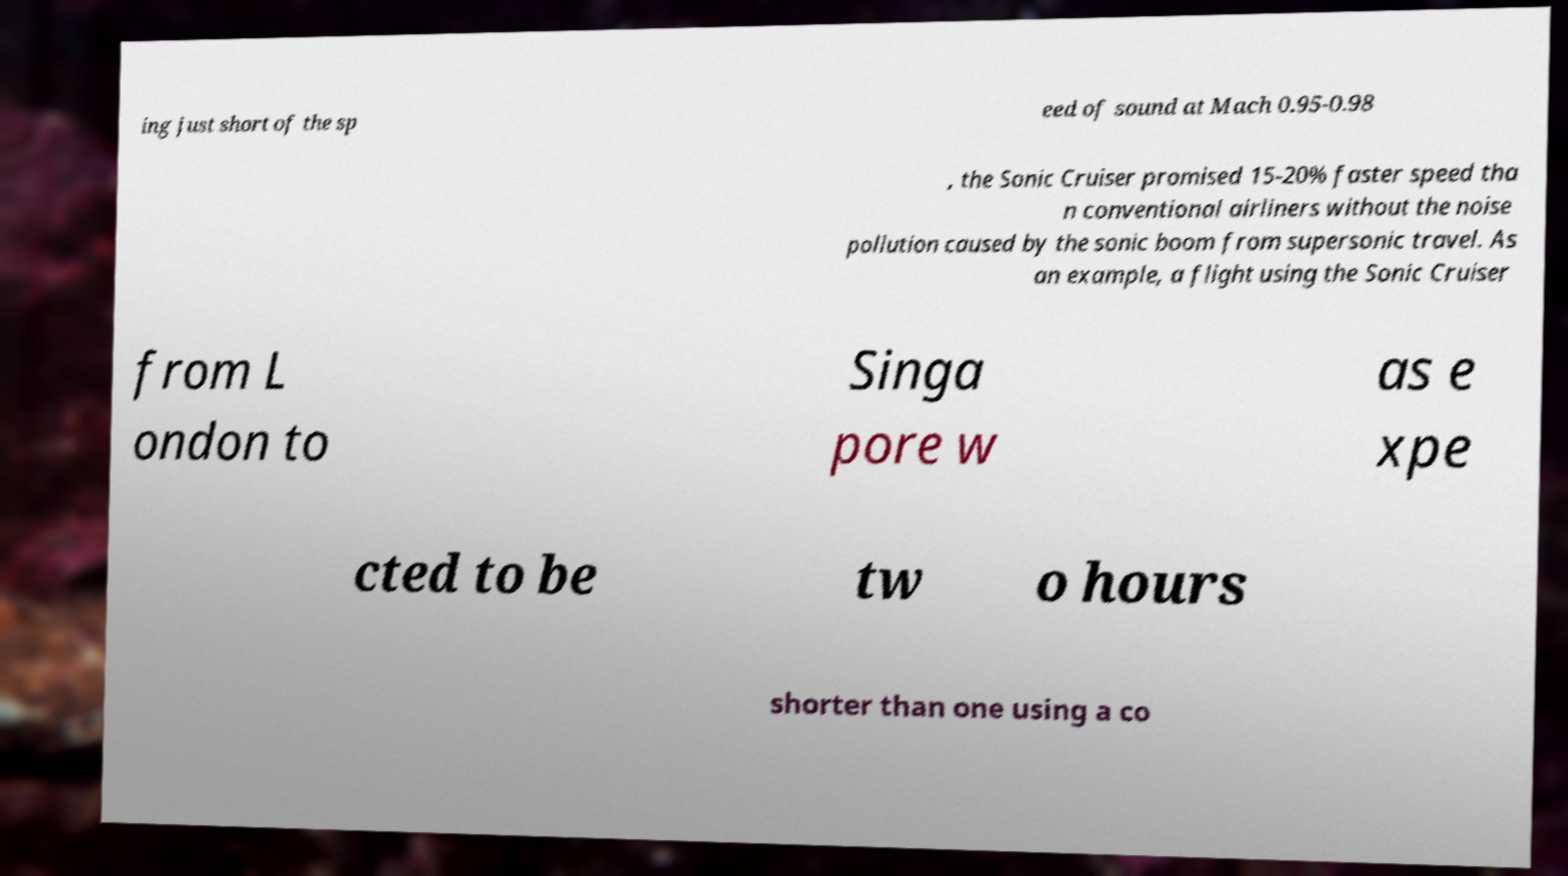Please read and relay the text visible in this image. What does it say? ing just short of the sp eed of sound at Mach 0.95-0.98 , the Sonic Cruiser promised 15-20% faster speed tha n conventional airliners without the noise pollution caused by the sonic boom from supersonic travel. As an example, a flight using the Sonic Cruiser from L ondon to Singa pore w as e xpe cted to be tw o hours shorter than one using a co 